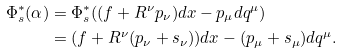Convert formula to latex. <formula><loc_0><loc_0><loc_500><loc_500>\Phi _ { s } ^ { \ast } ( \alpha ) & = \Phi _ { s } ^ { \ast } ( ( f + R ^ { \nu } p _ { \nu } ) d x - p _ { \mu } d q ^ { \mu } ) \\ & = ( f + R ^ { \nu } ( p _ { \nu } + s _ { \nu } ) ) d x - ( p _ { \mu } + s _ { \mu } ) d q ^ { \mu } .</formula> 